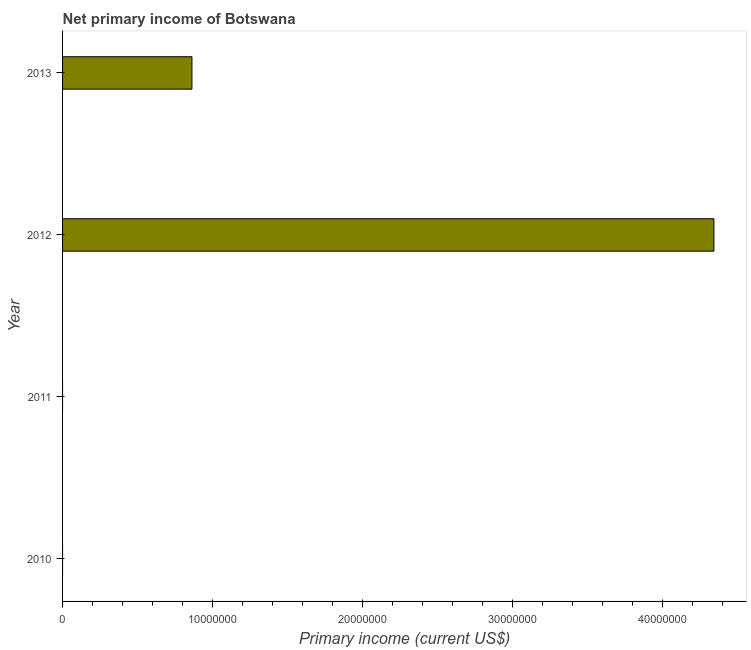Does the graph contain any zero values?
Provide a short and direct response. Yes. Does the graph contain grids?
Offer a very short reply. No. What is the title of the graph?
Your answer should be compact. Net primary income of Botswana. What is the label or title of the X-axis?
Provide a succinct answer. Primary income (current US$). What is the label or title of the Y-axis?
Your response must be concise. Year. What is the amount of primary income in 2012?
Your response must be concise. 4.35e+07. Across all years, what is the maximum amount of primary income?
Offer a very short reply. 4.35e+07. Across all years, what is the minimum amount of primary income?
Your answer should be compact. 0. What is the sum of the amount of primary income?
Your response must be concise. 5.21e+07. What is the average amount of primary income per year?
Keep it short and to the point. 1.30e+07. What is the median amount of primary income?
Your response must be concise. 4.32e+06. What is the ratio of the amount of primary income in 2012 to that in 2013?
Provide a succinct answer. 5.03. Is the amount of primary income in 2012 less than that in 2013?
Make the answer very short. No. Is the difference between the amount of primary income in 2012 and 2013 greater than the difference between any two years?
Offer a very short reply. No. What is the difference between the highest and the lowest amount of primary income?
Give a very brief answer. 4.35e+07. In how many years, is the amount of primary income greater than the average amount of primary income taken over all years?
Provide a short and direct response. 1. How many bars are there?
Ensure brevity in your answer.  2. Are all the bars in the graph horizontal?
Keep it short and to the point. Yes. How many years are there in the graph?
Your answer should be very brief. 4. What is the difference between two consecutive major ticks on the X-axis?
Your response must be concise. 1.00e+07. Are the values on the major ticks of X-axis written in scientific E-notation?
Keep it short and to the point. No. What is the Primary income (current US$) of 2010?
Offer a very short reply. 0. What is the Primary income (current US$) in 2011?
Provide a short and direct response. 0. What is the Primary income (current US$) of 2012?
Your answer should be compact. 4.35e+07. What is the Primary income (current US$) of 2013?
Provide a succinct answer. 8.63e+06. What is the difference between the Primary income (current US$) in 2012 and 2013?
Ensure brevity in your answer.  3.48e+07. What is the ratio of the Primary income (current US$) in 2012 to that in 2013?
Your answer should be compact. 5.03. 